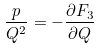<formula> <loc_0><loc_0><loc_500><loc_500>\frac { p } { Q ^ { 2 } } = - \frac { \partial F _ { 3 } } { \partial Q }</formula> 